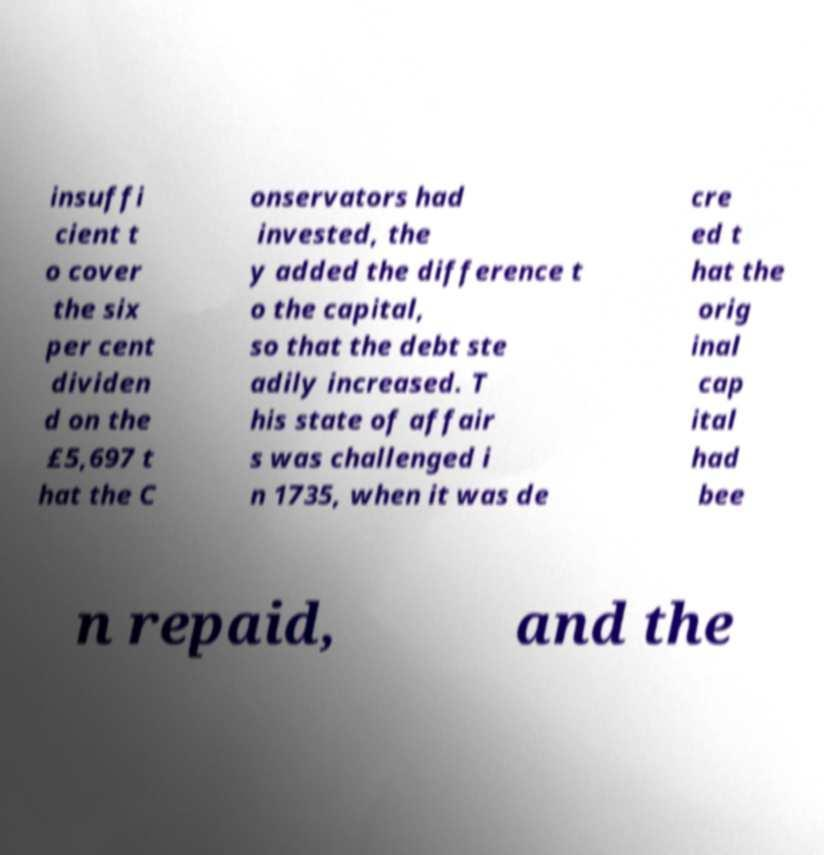Can you accurately transcribe the text from the provided image for me? insuffi cient t o cover the six per cent dividen d on the £5,697 t hat the C onservators had invested, the y added the difference t o the capital, so that the debt ste adily increased. T his state of affair s was challenged i n 1735, when it was de cre ed t hat the orig inal cap ital had bee n repaid, and the 